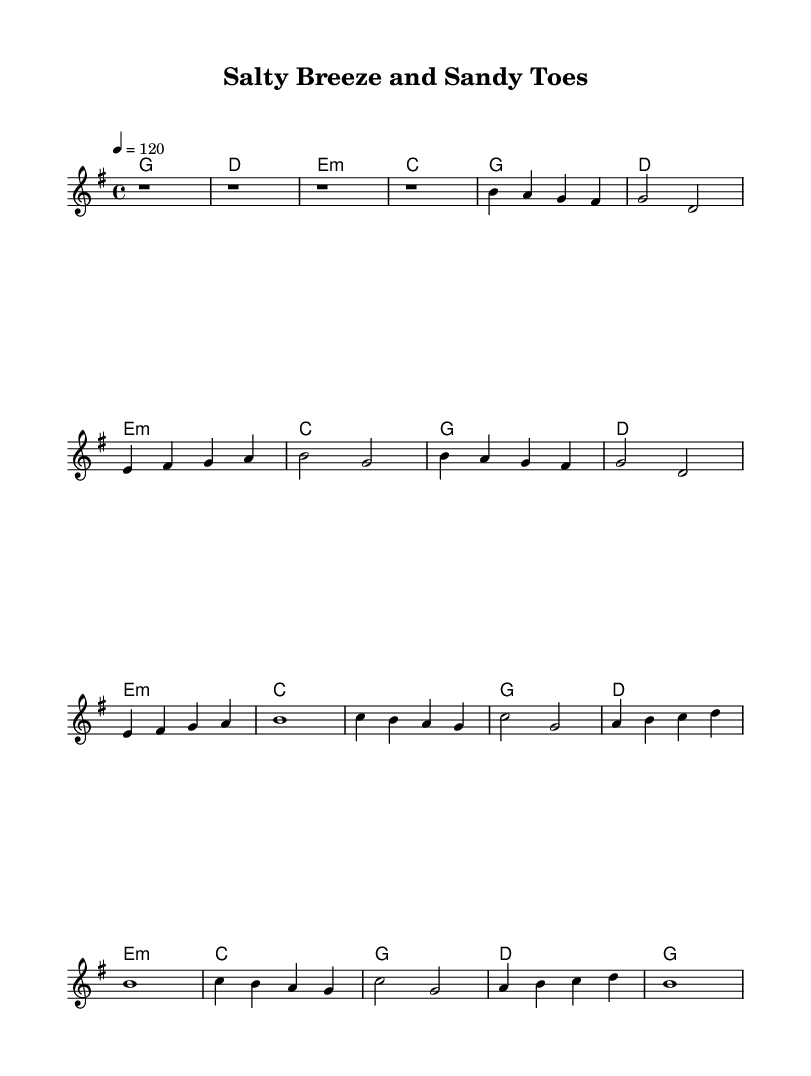What is the key signature of this music? The key signature is G major, which has one sharp (F#).
Answer: G major What is the time signature of this music? The time signature is 4/4, indicating four beats per measure.
Answer: 4/4 What is the tempo of this music? The tempo is set to 120 beats per minute, as indicated at the beginning of the score.
Answer: 120 How many measures are in the intro section? The intro section has four measures, each represented by 'r1', which stands for a rest of one whole note.
Answer: 4 What chord follows the first G major chord in the verse? The chord following the first G major in the verse is D major, as shown in the chord symbols written above the melody.
Answer: D What is the structure of the chorus? The chorus follows the pattern of two repeated lines with unique melodies, utilizing a mix of chords indicated in the score.
Answer: AABB What mood does the title "Salty Breeze and Sandy Toes" suggest about the song? The title suggests a cheerful and relaxed atmosphere, typical of upbeat country tunes celebrating beach culture.
Answer: Cheerful 